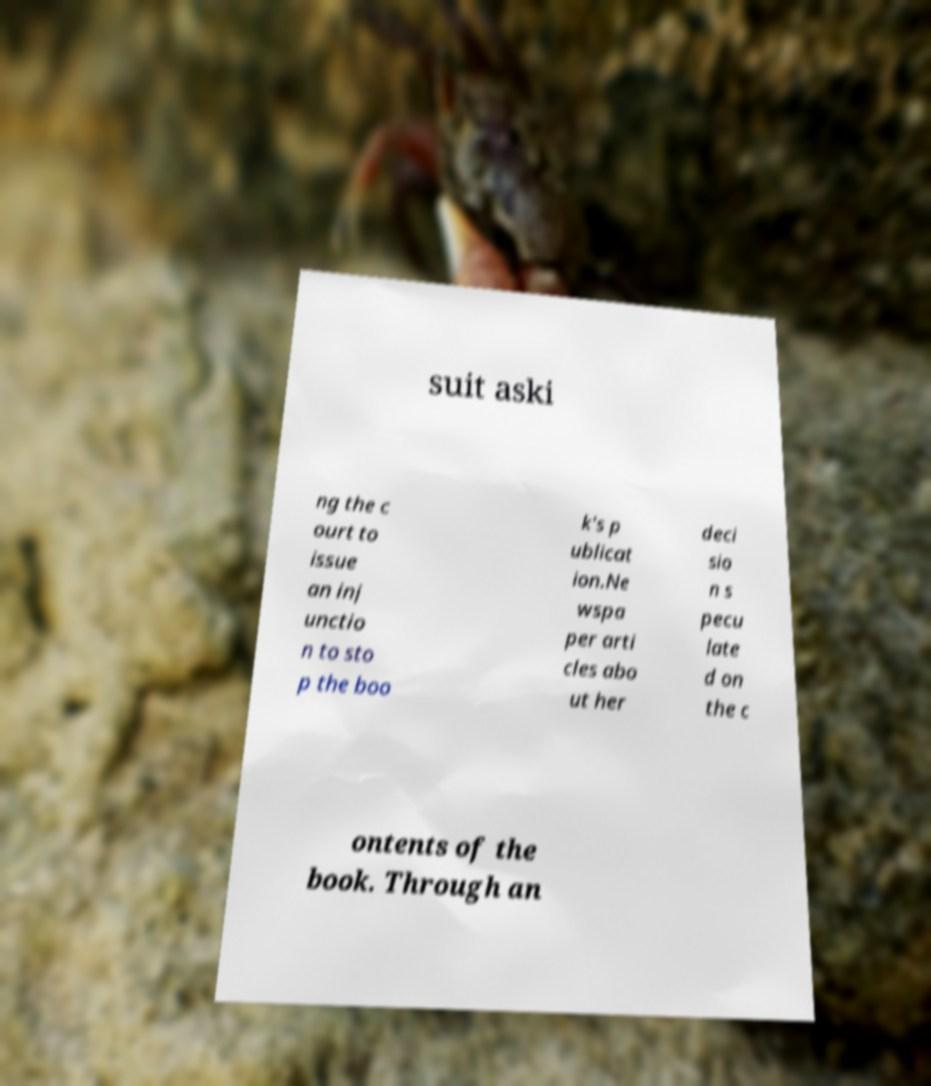Could you extract and type out the text from this image? suit aski ng the c ourt to issue an inj unctio n to sto p the boo k's p ublicat ion.Ne wspa per arti cles abo ut her deci sio n s pecu late d on the c ontents of the book. Through an 